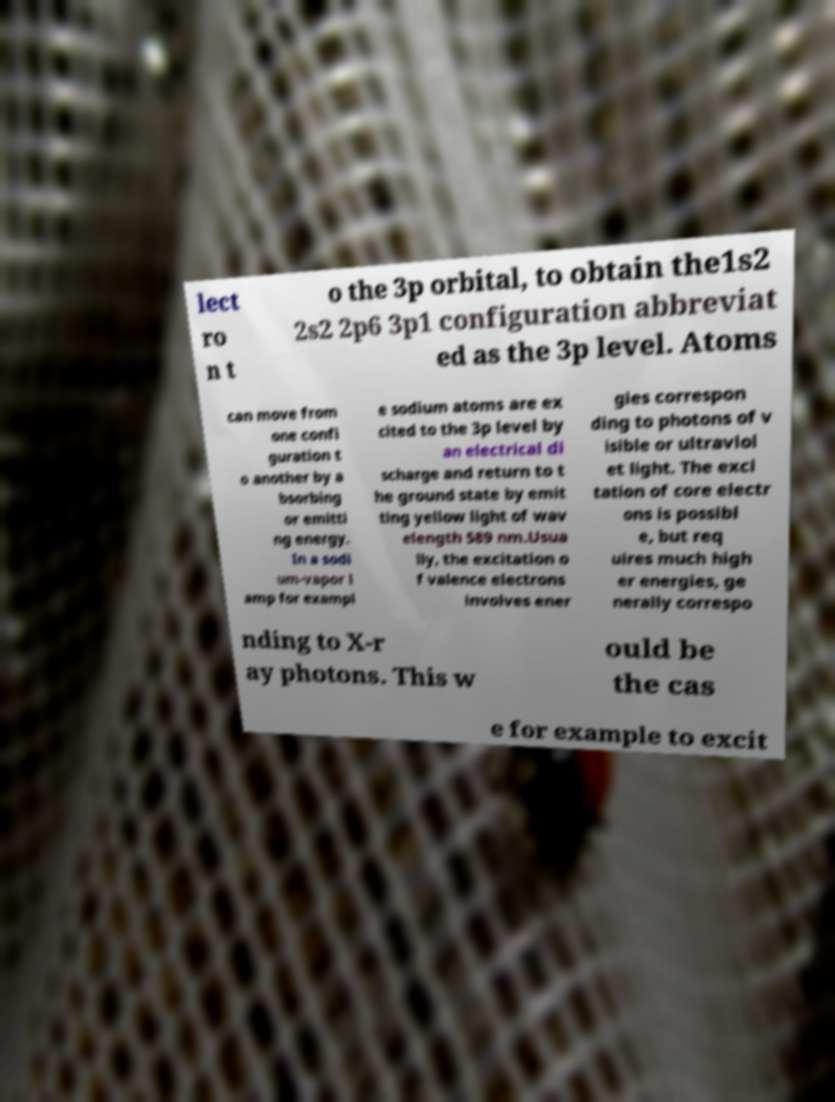Please identify and transcribe the text found in this image. lect ro n t o the 3p orbital, to obtain the1s2 2s2 2p6 3p1 configuration abbreviat ed as the 3p level. Atoms can move from one confi guration t o another by a bsorbing or emitti ng energy. In a sodi um-vapor l amp for exampl e sodium atoms are ex cited to the 3p level by an electrical di scharge and return to t he ground state by emit ting yellow light of wav elength 589 nm.Usua lly, the excitation o f valence electrons involves ener gies correspon ding to photons of v isible or ultraviol et light. The exci tation of core electr ons is possibl e, but req uires much high er energies, ge nerally correspo nding to X-r ay photons. This w ould be the cas e for example to excit 